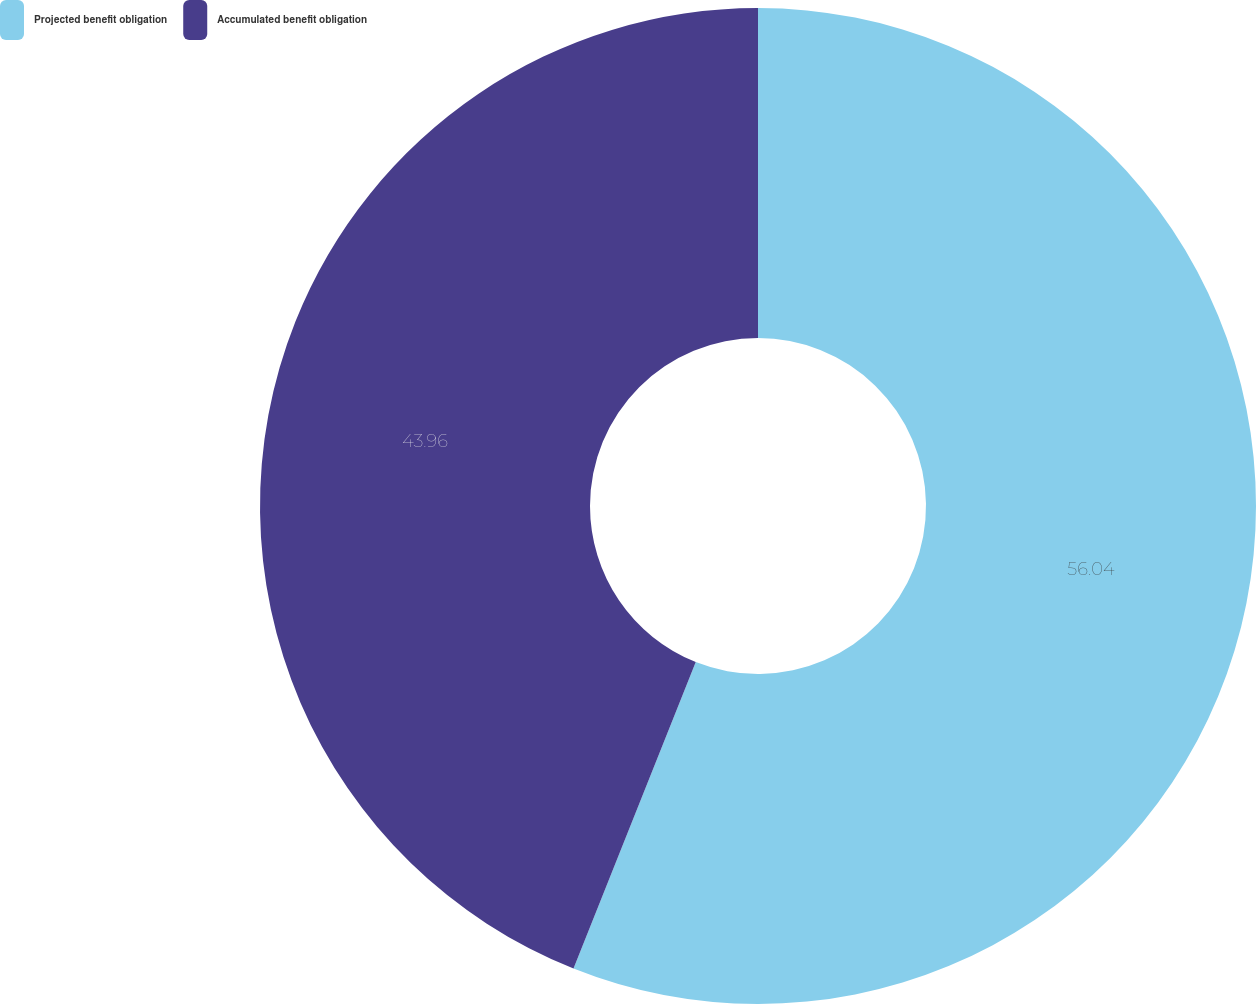Convert chart. <chart><loc_0><loc_0><loc_500><loc_500><pie_chart><fcel>Projected benefit obligation<fcel>Accumulated benefit obligation<nl><fcel>56.04%<fcel>43.96%<nl></chart> 